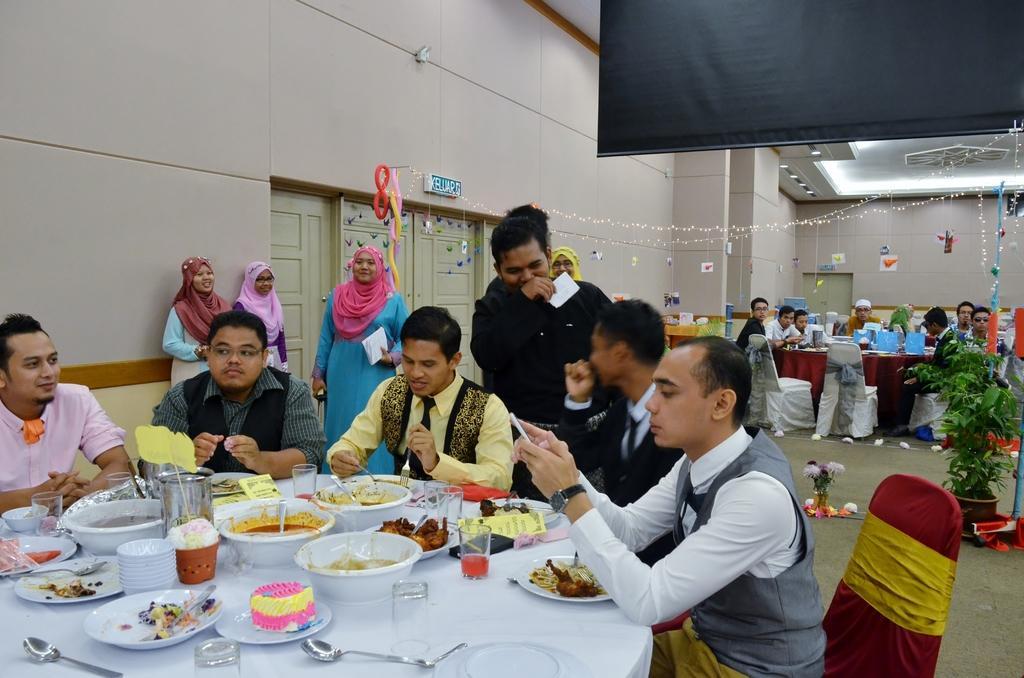In one or two sentences, can you explain what this image depicts? In this image we can see some persons that are sitting and standing on the floor. In addition to this we can see tables, cutlery, crockery, food, walls, lights, plants, decors, doors and floor. 